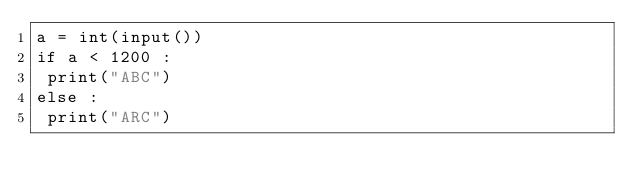Convert code to text. <code><loc_0><loc_0><loc_500><loc_500><_Python_>a = int(input())
if a < 1200 :
 print("ABC")
else :
 print("ARC")
</code> 